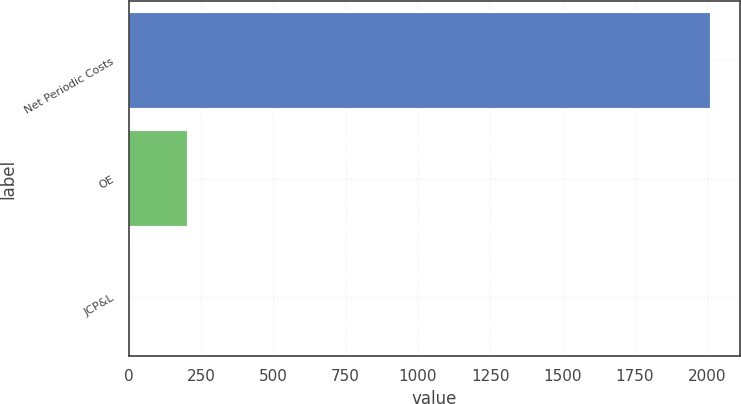Convert chart to OTSL. <chart><loc_0><loc_0><loc_500><loc_500><bar_chart><fcel>Net Periodic Costs<fcel>OE<fcel>JCP&L<nl><fcel>2011<fcel>202.9<fcel>2<nl></chart> 